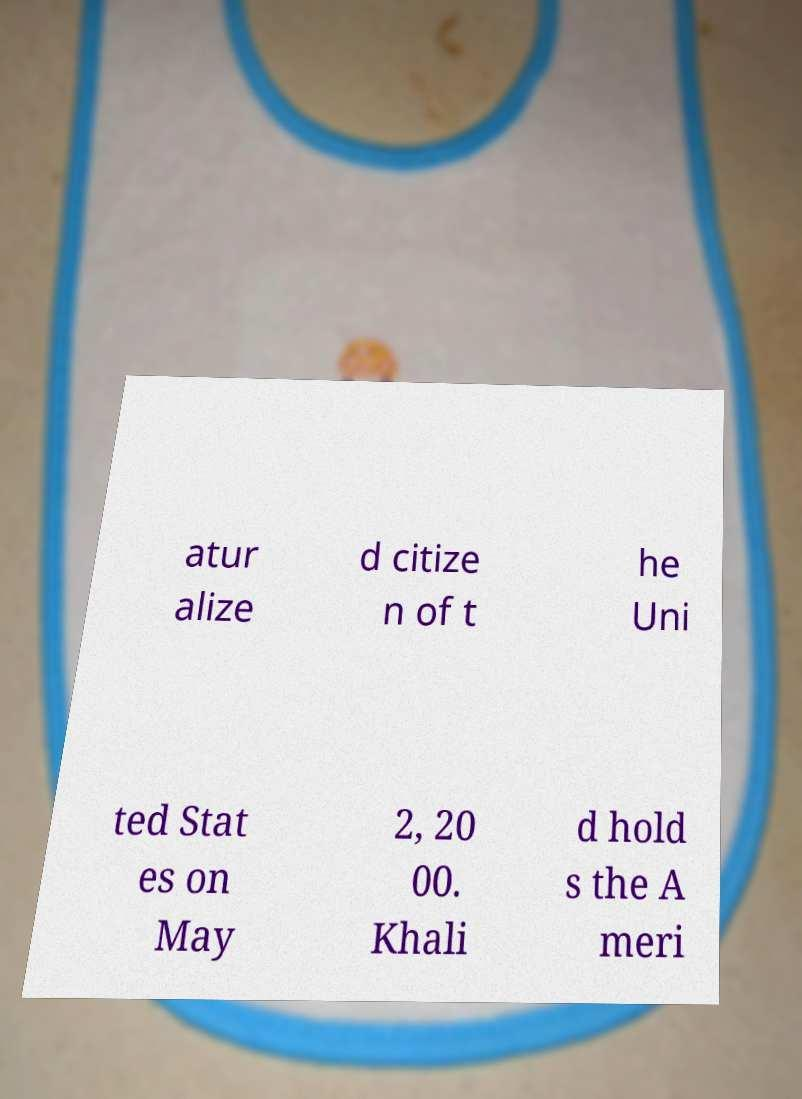There's text embedded in this image that I need extracted. Can you transcribe it verbatim? atur alize d citize n of t he Uni ted Stat es on May 2, 20 00. Khali d hold s the A meri 